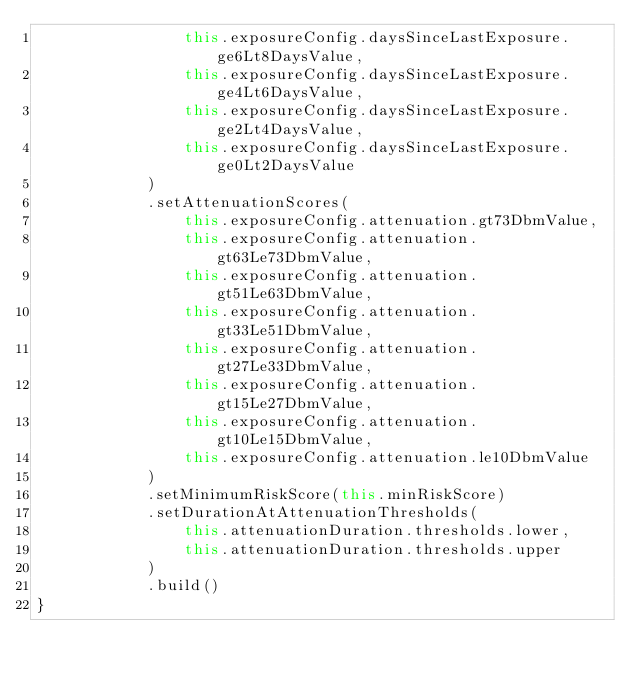<code> <loc_0><loc_0><loc_500><loc_500><_Kotlin_>                this.exposureConfig.daysSinceLastExposure.ge6Lt8DaysValue,
                this.exposureConfig.daysSinceLastExposure.ge4Lt6DaysValue,
                this.exposureConfig.daysSinceLastExposure.ge2Lt4DaysValue,
                this.exposureConfig.daysSinceLastExposure.ge0Lt2DaysValue
            )
            .setAttenuationScores(
                this.exposureConfig.attenuation.gt73DbmValue,
                this.exposureConfig.attenuation.gt63Le73DbmValue,
                this.exposureConfig.attenuation.gt51Le63DbmValue,
                this.exposureConfig.attenuation.gt33Le51DbmValue,
                this.exposureConfig.attenuation.gt27Le33DbmValue,
                this.exposureConfig.attenuation.gt15Le27DbmValue,
                this.exposureConfig.attenuation.gt10Le15DbmValue,
                this.exposureConfig.attenuation.le10DbmValue
            )
            .setMinimumRiskScore(this.minRiskScore)
            .setDurationAtAttenuationThresholds(
                this.attenuationDuration.thresholds.lower,
                this.attenuationDuration.thresholds.upper
            )
            .build()
}
</code> 